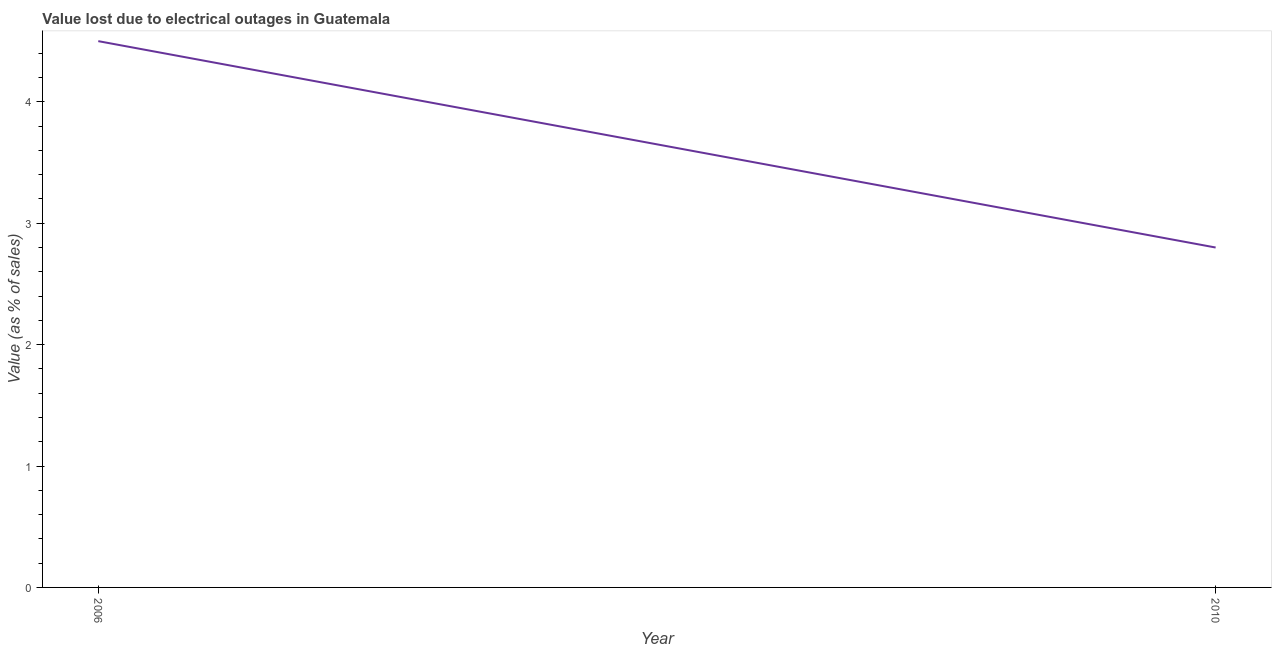What is the value lost due to electrical outages in 2010?
Provide a short and direct response. 2.8. Across all years, what is the maximum value lost due to electrical outages?
Offer a very short reply. 4.5. In which year was the value lost due to electrical outages maximum?
Keep it short and to the point. 2006. What is the difference between the value lost due to electrical outages in 2006 and 2010?
Your answer should be very brief. 1.7. What is the average value lost due to electrical outages per year?
Offer a terse response. 3.65. What is the median value lost due to electrical outages?
Provide a succinct answer. 3.65. What is the ratio of the value lost due to electrical outages in 2006 to that in 2010?
Provide a succinct answer. 1.61. What is the difference between two consecutive major ticks on the Y-axis?
Make the answer very short. 1. Are the values on the major ticks of Y-axis written in scientific E-notation?
Give a very brief answer. No. Does the graph contain grids?
Keep it short and to the point. No. What is the title of the graph?
Offer a very short reply. Value lost due to electrical outages in Guatemala. What is the label or title of the Y-axis?
Keep it short and to the point. Value (as % of sales). What is the Value (as % of sales) in 2006?
Your answer should be very brief. 4.5. What is the Value (as % of sales) of 2010?
Make the answer very short. 2.8. What is the difference between the Value (as % of sales) in 2006 and 2010?
Provide a succinct answer. 1.7. What is the ratio of the Value (as % of sales) in 2006 to that in 2010?
Offer a very short reply. 1.61. 